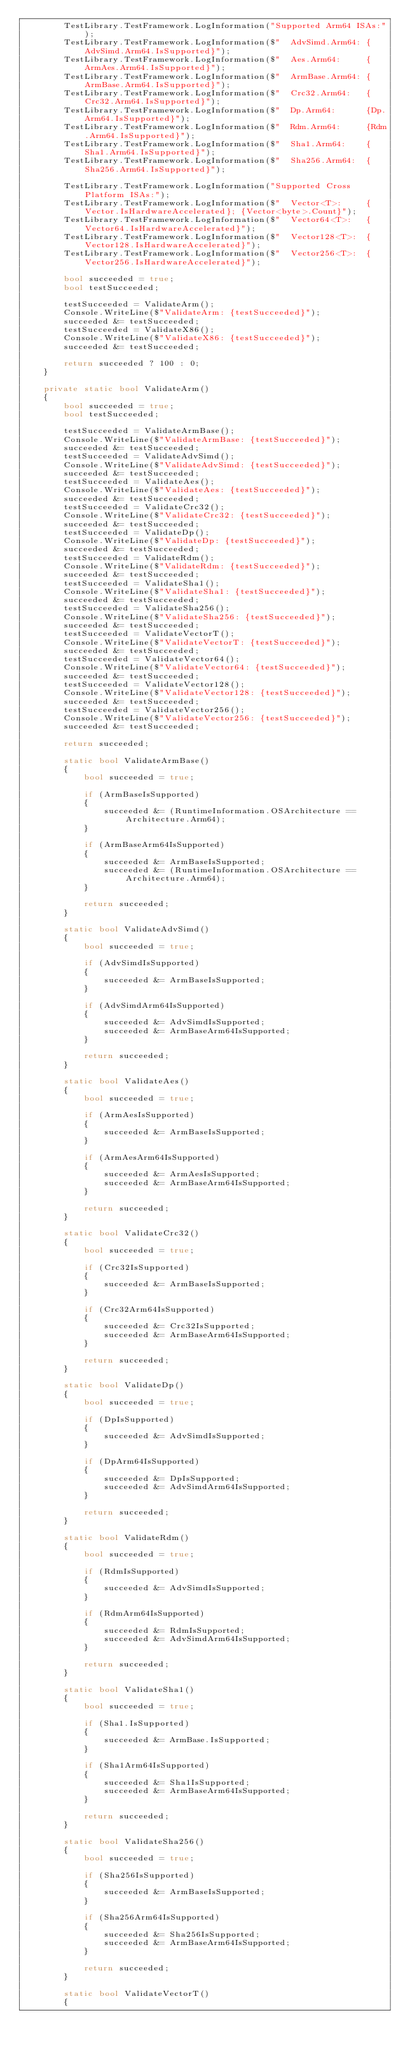<code> <loc_0><loc_0><loc_500><loc_500><_C#_>        TestLibrary.TestFramework.LogInformation("Supported Arm64 ISAs:");
        TestLibrary.TestFramework.LogInformation($"  AdvSimd.Arm64: {AdvSimd.Arm64.IsSupported}");
        TestLibrary.TestFramework.LogInformation($"  Aes.Arm64:     {ArmAes.Arm64.IsSupported}");
        TestLibrary.TestFramework.LogInformation($"  ArmBase.Arm64: {ArmBase.Arm64.IsSupported}");
        TestLibrary.TestFramework.LogInformation($"  Crc32.Arm64:   {Crc32.Arm64.IsSupported}");
        TestLibrary.TestFramework.LogInformation($"  Dp.Arm64:      {Dp.Arm64.IsSupported}");
        TestLibrary.TestFramework.LogInformation($"  Rdm.Arm64:     {Rdm.Arm64.IsSupported}");
        TestLibrary.TestFramework.LogInformation($"  Sha1.Arm64:    {Sha1.Arm64.IsSupported}");
        TestLibrary.TestFramework.LogInformation($"  Sha256.Arm64:  {Sha256.Arm64.IsSupported}");

        TestLibrary.TestFramework.LogInformation("Supported Cross Platform ISAs:");
        TestLibrary.TestFramework.LogInformation($"  Vector<T>:     {Vector.IsHardwareAccelerated}; {Vector<byte>.Count}");
        TestLibrary.TestFramework.LogInformation($"  Vector64<T>:   {Vector64.IsHardwareAccelerated}");
        TestLibrary.TestFramework.LogInformation($"  Vector128<T>:  {Vector128.IsHardwareAccelerated}");
        TestLibrary.TestFramework.LogInformation($"  Vector256<T>:  {Vector256.IsHardwareAccelerated}");

        bool succeeded = true;
        bool testSucceeded;

        testSucceeded = ValidateArm();
        Console.WriteLine($"ValidateArm: {testSucceeded}");
        succeeded &= testSucceeded;
        testSucceeded = ValidateX86();
        Console.WriteLine($"ValidateX86: {testSucceeded}");
        succeeded &= testSucceeded;

        return succeeded ? 100 : 0;
    }

    private static bool ValidateArm()
    {
        bool succeeded = true;
        bool testSucceeded;

        testSucceeded = ValidateArmBase();
        Console.WriteLine($"ValidateArmBase: {testSucceeded}");
        succeeded &= testSucceeded;
        testSucceeded = ValidateAdvSimd();
        Console.WriteLine($"ValidateAdvSimd: {testSucceeded}");
        succeeded &= testSucceeded;
        testSucceeded = ValidateAes();
        Console.WriteLine($"ValidateAes: {testSucceeded}");
        succeeded &= testSucceeded;
        testSucceeded = ValidateCrc32();
        Console.WriteLine($"ValidateCrc32: {testSucceeded}");
        succeeded &= testSucceeded;
        testSucceeded = ValidateDp();
        Console.WriteLine($"ValidateDp: {testSucceeded}");
        succeeded &= testSucceeded;
        testSucceeded = ValidateRdm();
        Console.WriteLine($"ValidateRdm: {testSucceeded}");
        succeeded &= testSucceeded;
        testSucceeded = ValidateSha1();
        Console.WriteLine($"ValidateSha1: {testSucceeded}");
        succeeded &= testSucceeded;
        testSucceeded = ValidateSha256();
        Console.WriteLine($"ValidateSha256: {testSucceeded}");
        succeeded &= testSucceeded;
        testSucceeded = ValidateVectorT();
        Console.WriteLine($"ValidateVectorT: {testSucceeded}");
        succeeded &= testSucceeded;
        testSucceeded = ValidateVector64();
        Console.WriteLine($"ValidateVector64: {testSucceeded}");
        succeeded &= testSucceeded;
        testSucceeded = ValidateVector128();
        Console.WriteLine($"ValidateVector128: {testSucceeded}");
        succeeded &= testSucceeded;
        testSucceeded = ValidateVector256();
        Console.WriteLine($"ValidateVector256: {testSucceeded}");
        succeeded &= testSucceeded;

        return succeeded;

        static bool ValidateArmBase()
        {
            bool succeeded = true;

            if (ArmBaseIsSupported)
            {
                succeeded &= (RuntimeInformation.OSArchitecture == Architecture.Arm64);
            }

            if (ArmBaseArm64IsSupported)
            {
                succeeded &= ArmBaseIsSupported;
                succeeded &= (RuntimeInformation.OSArchitecture == Architecture.Arm64);
            }

            return succeeded;
        }

        static bool ValidateAdvSimd()
        {
            bool succeeded = true;

            if (AdvSimdIsSupported)
            {
                succeeded &= ArmBaseIsSupported;
            }

            if (AdvSimdArm64IsSupported)
            {
                succeeded &= AdvSimdIsSupported;
                succeeded &= ArmBaseArm64IsSupported;
            }

            return succeeded;
        }

        static bool ValidateAes()
        {
            bool succeeded = true;

            if (ArmAesIsSupported)
            {
                succeeded &= ArmBaseIsSupported;
            }

            if (ArmAesArm64IsSupported)
            {
                succeeded &= ArmAesIsSupported;
                succeeded &= ArmBaseArm64IsSupported;
            }

            return succeeded;
        }

        static bool ValidateCrc32()
        {
            bool succeeded = true;

            if (Crc32IsSupported)
            {
                succeeded &= ArmBaseIsSupported;
            }

            if (Crc32Arm64IsSupported)
            {
                succeeded &= Crc32IsSupported;
                succeeded &= ArmBaseArm64IsSupported;
            }

            return succeeded;
        }

        static bool ValidateDp()
        {
            bool succeeded = true;

            if (DpIsSupported)
            {
                succeeded &= AdvSimdIsSupported;
            }

            if (DpArm64IsSupported)
            {
                succeeded &= DpIsSupported;
                succeeded &= AdvSimdArm64IsSupported;
            }

            return succeeded;
        }

        static bool ValidateRdm()
        {
            bool succeeded = true;

            if (RdmIsSupported)
            {
                succeeded &= AdvSimdIsSupported;
            }

            if (RdmArm64IsSupported)
            {
                succeeded &= RdmIsSupported;
                succeeded &= AdvSimdArm64IsSupported;
            }

            return succeeded;
        }

        static bool ValidateSha1()
        {
            bool succeeded = true;

            if (Sha1.IsSupported)
            {
                succeeded &= ArmBase.IsSupported;
            }

            if (Sha1Arm64IsSupported)
            {
                succeeded &= Sha1IsSupported;
                succeeded &= ArmBaseArm64IsSupported;
            }

            return succeeded;
        }

        static bool ValidateSha256()
        {
            bool succeeded = true;

            if (Sha256IsSupported)
            {
                succeeded &= ArmBaseIsSupported;
            }

            if (Sha256Arm64IsSupported)
            {
                succeeded &= Sha256IsSupported;
                succeeded &= ArmBaseArm64IsSupported;
            }

            return succeeded;
        }

        static bool ValidateVectorT()
        {</code> 